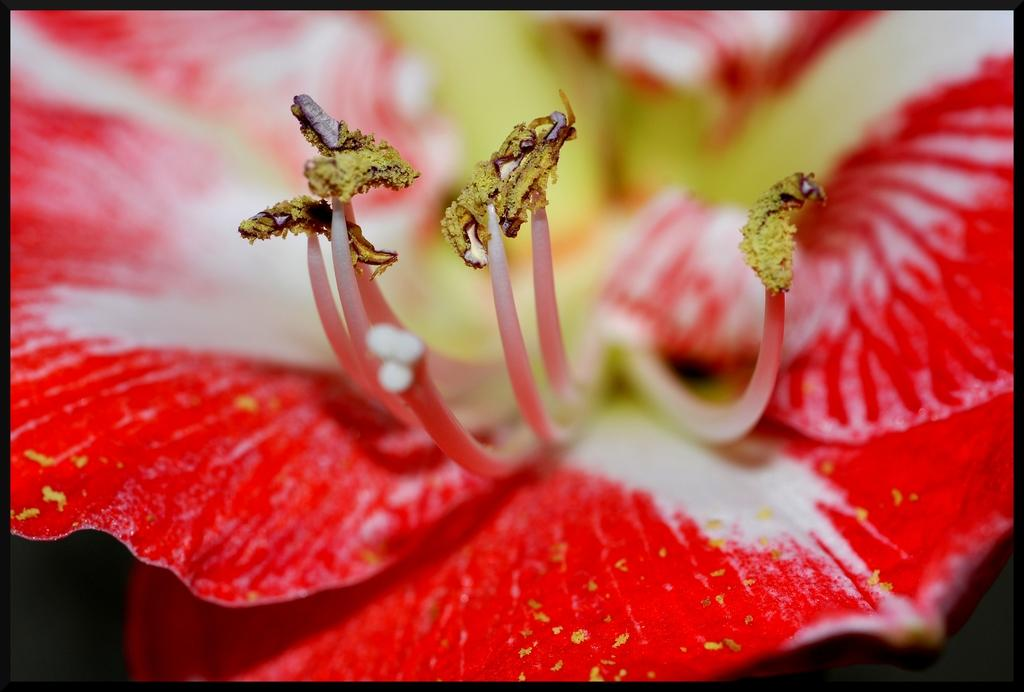What is present in the image? There is a flower in the image. Can you describe the flower in the image? The flower is red in color. Is the flower wearing a mask in the image? No, the flower is not wearing a mask in the image, as flowers do not wear masks. 